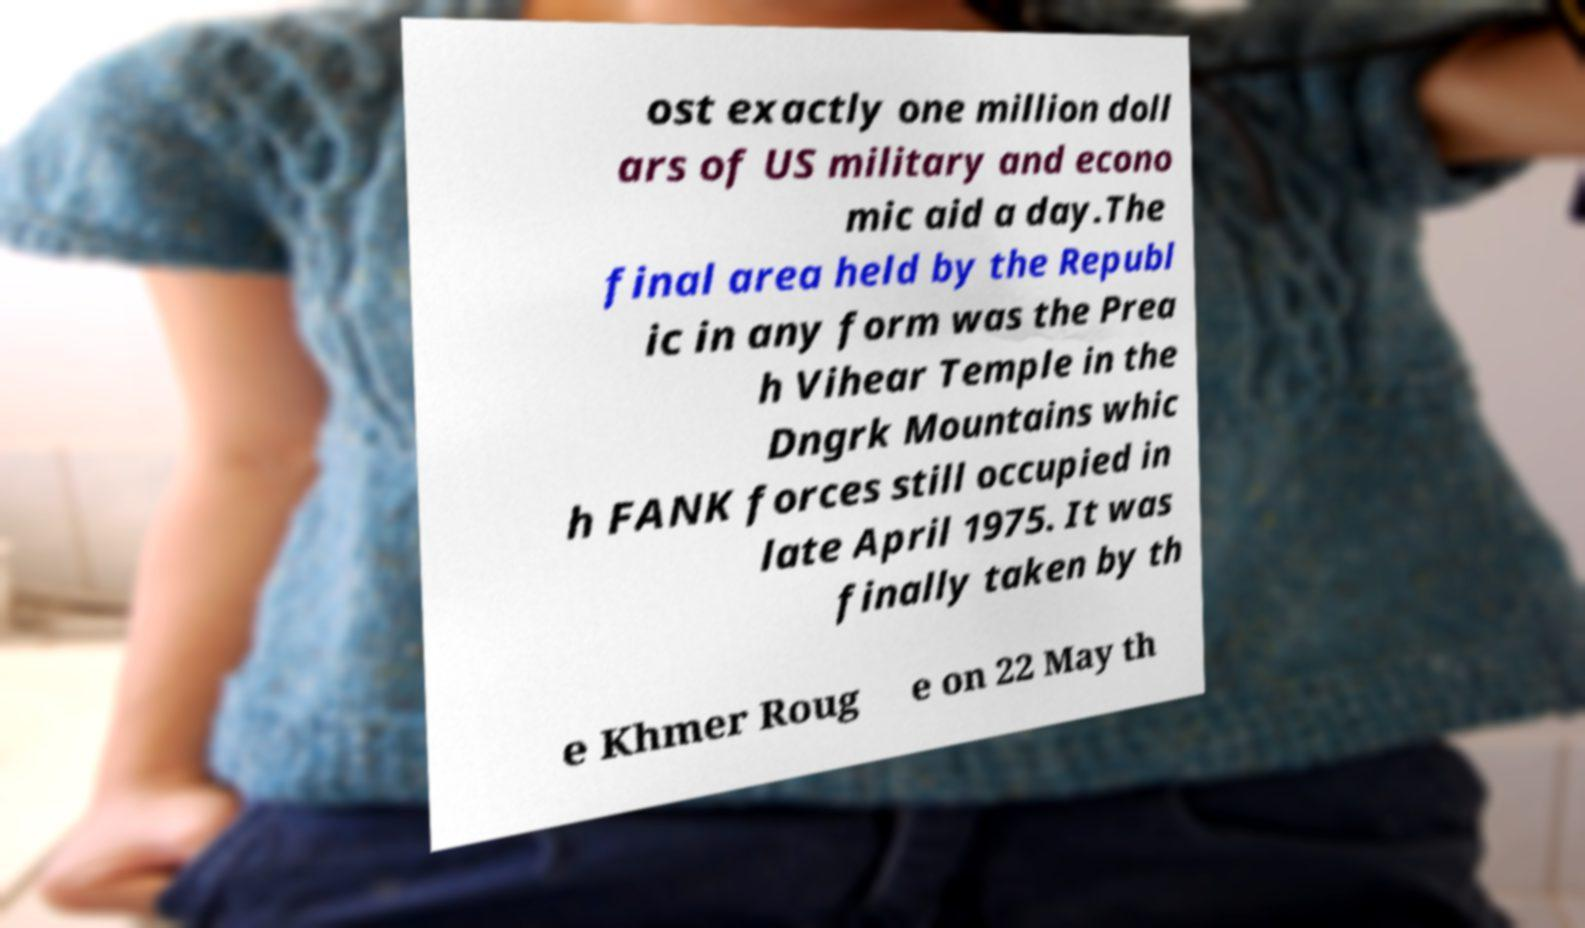Could you extract and type out the text from this image? ost exactly one million doll ars of US military and econo mic aid a day.The final area held by the Republ ic in any form was the Prea h Vihear Temple in the Dngrk Mountains whic h FANK forces still occupied in late April 1975. It was finally taken by th e Khmer Roug e on 22 May th 